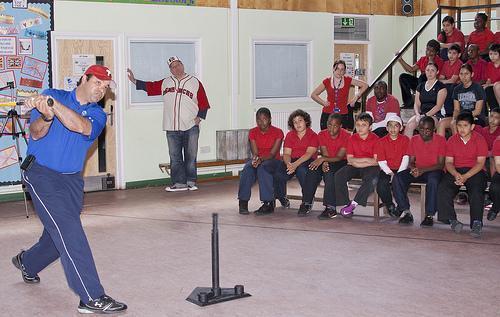How many women with red tops are standing?
Give a very brief answer. 1. 